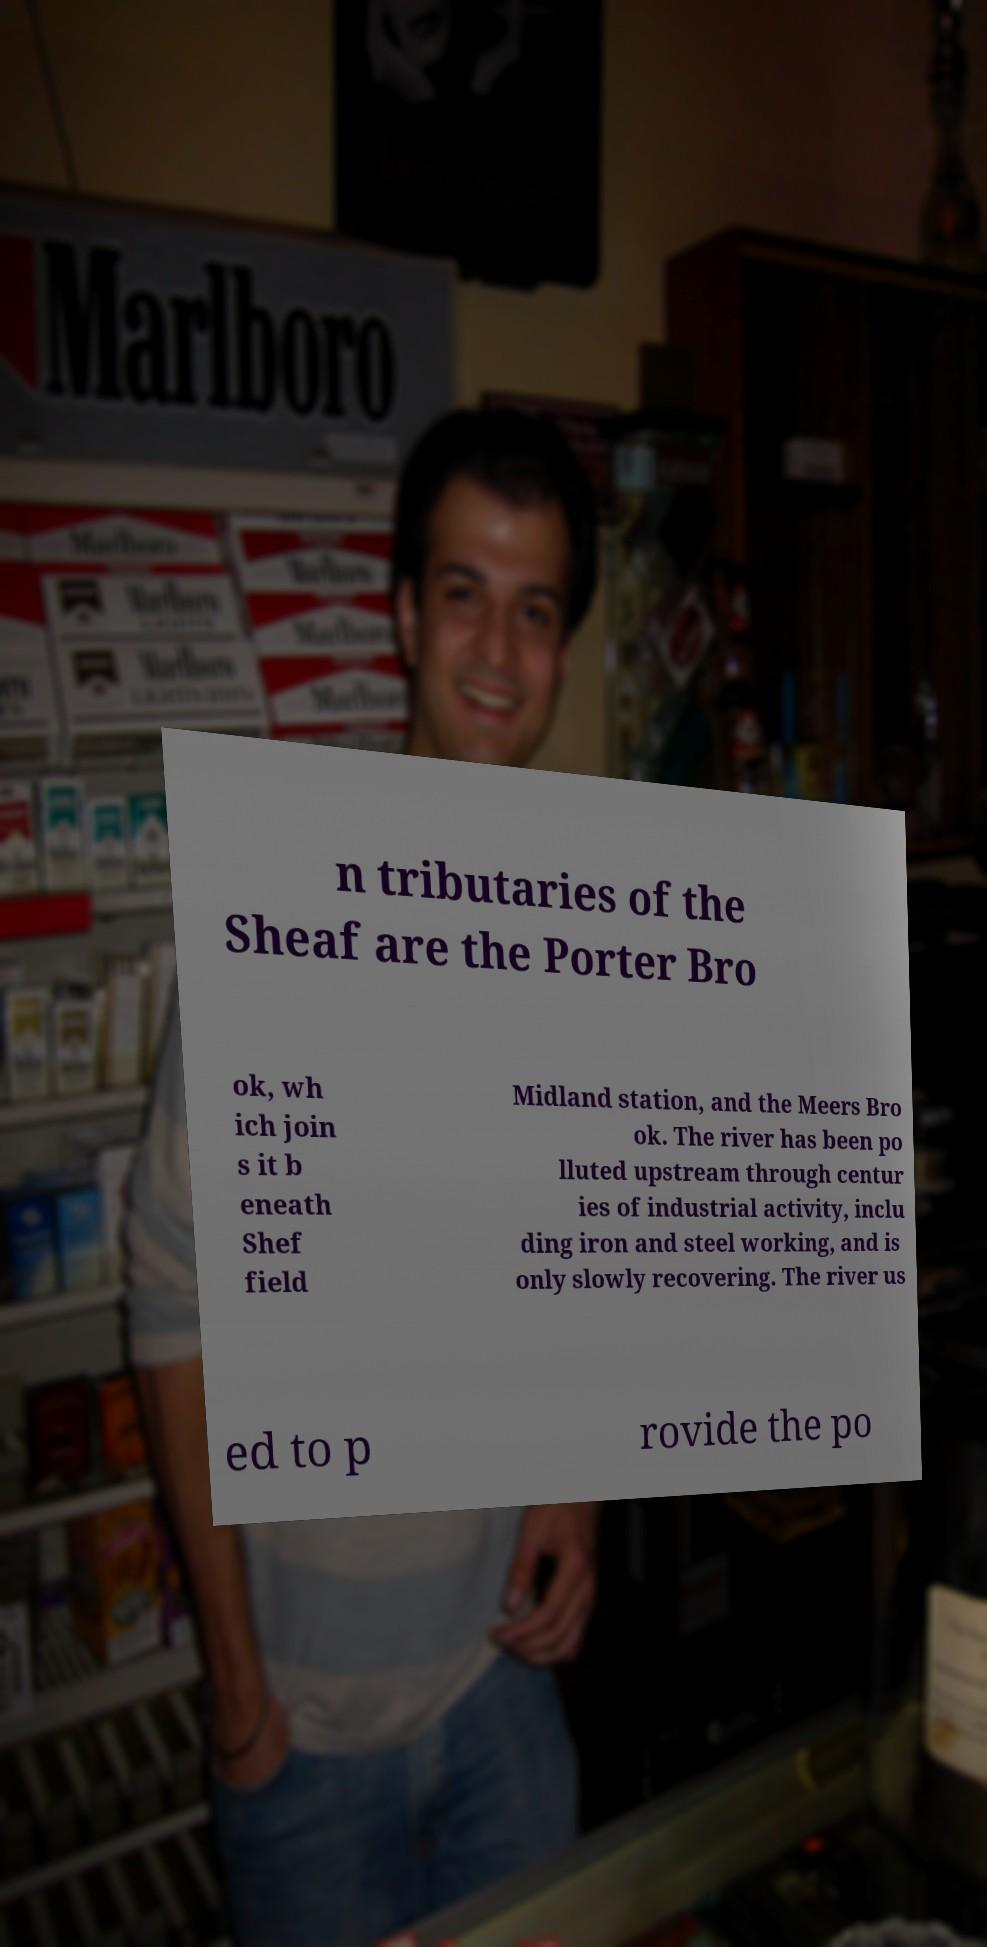Please read and relay the text visible in this image. What does it say? n tributaries of the Sheaf are the Porter Bro ok, wh ich join s it b eneath Shef field Midland station, and the Meers Bro ok. The river has been po lluted upstream through centur ies of industrial activity, inclu ding iron and steel working, and is only slowly recovering. The river us ed to p rovide the po 